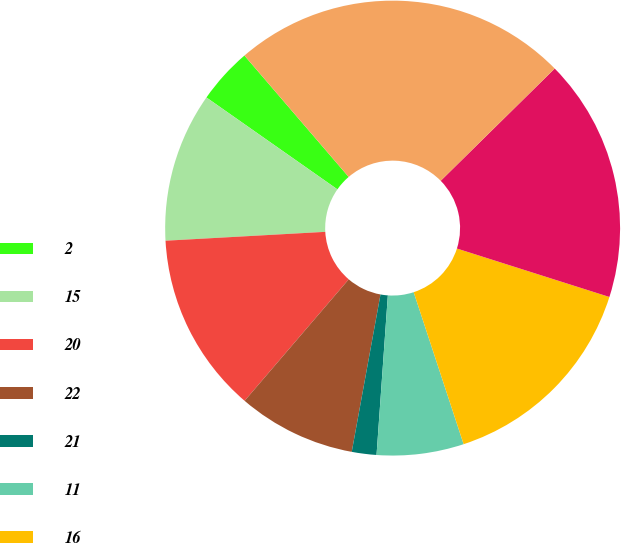Convert chart to OTSL. <chart><loc_0><loc_0><loc_500><loc_500><pie_chart><fcel>2<fcel>15<fcel>20<fcel>22<fcel>21<fcel>11<fcel>16<fcel>6<fcel>13<nl><fcel>3.97%<fcel>10.62%<fcel>12.84%<fcel>8.4%<fcel>1.75%<fcel>6.18%<fcel>15.05%<fcel>17.27%<fcel>23.92%<nl></chart> 